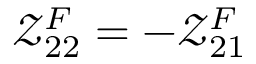<formula> <loc_0><loc_0><loc_500><loc_500>\mathcal { Z } _ { 2 2 } ^ { F } = - \mathcal { Z } _ { 2 1 } ^ { F }</formula> 